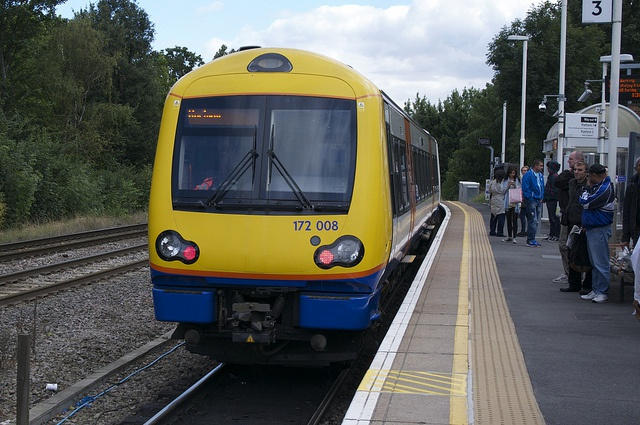Describe the objects in this image and their specific colors. I can see train in black, navy, olive, and gray tones, people in black, navy, darkblue, and gray tones, people in black and gray tones, people in black, navy, blue, and gray tones, and people in black and gray tones in this image. 